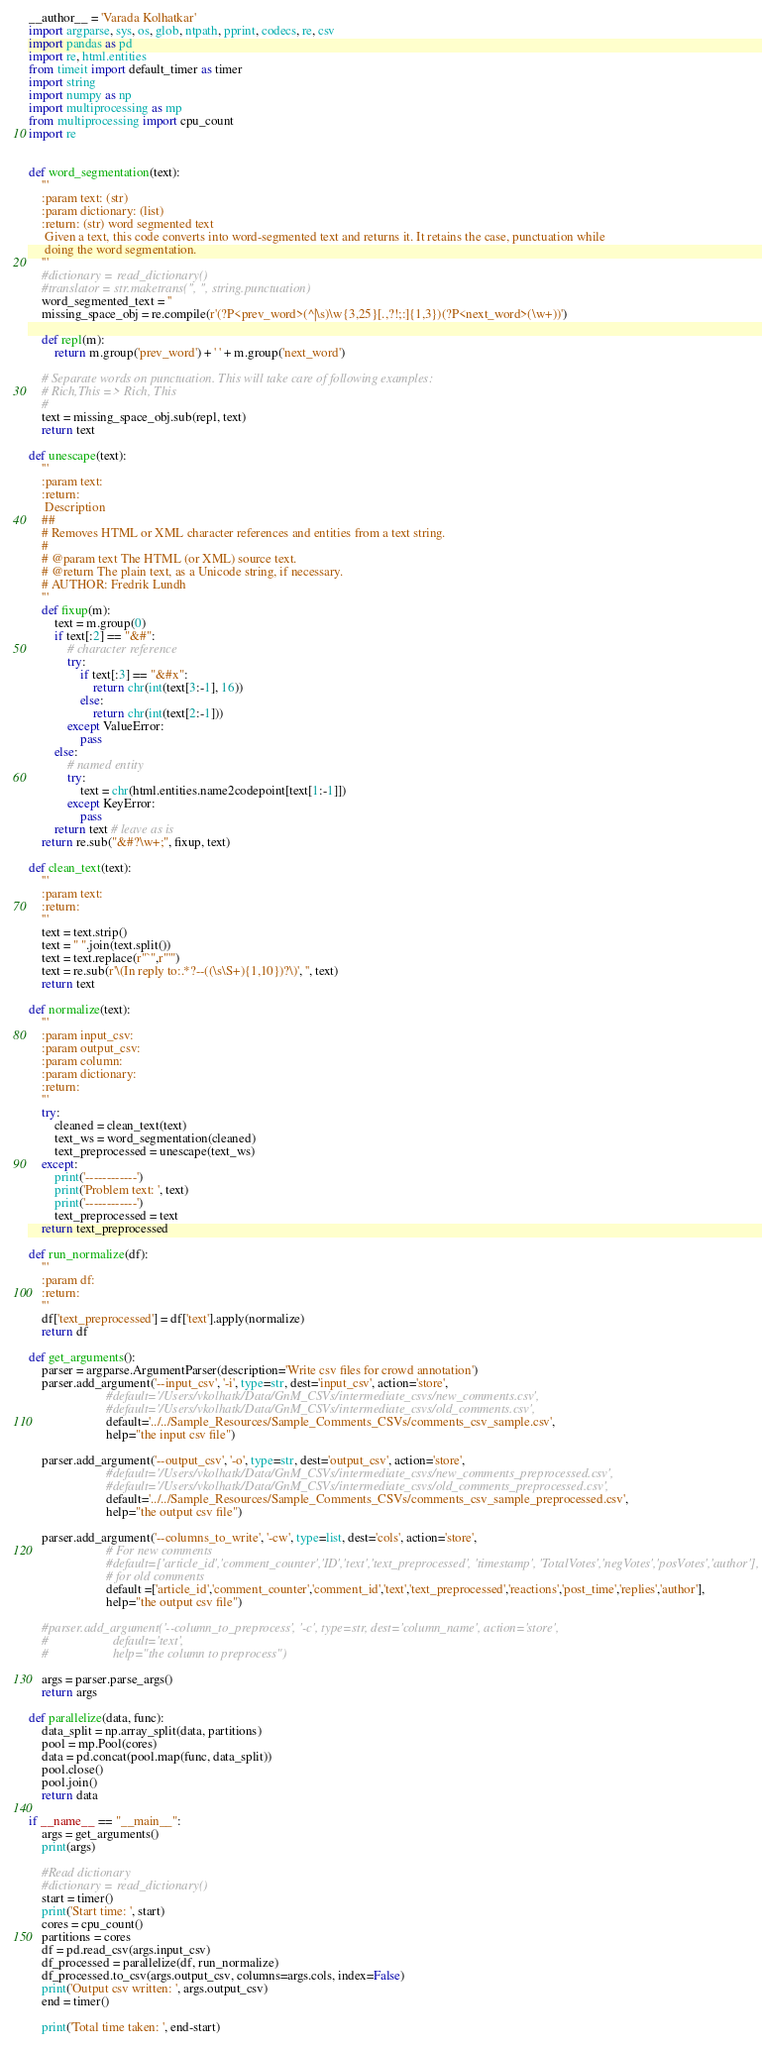<code> <loc_0><loc_0><loc_500><loc_500><_Python_>__author__ = 'Varada Kolhatkar'
import argparse, sys, os, glob, ntpath, pprint, codecs, re, csv
import pandas as pd
import re, html.entities
from timeit import default_timer as timer
import string
import numpy as np
import multiprocessing as mp
from multiprocessing import cpu_count
import re


def word_segmentation(text):
    '''
    :param text: (str)
    :param dictionary: (list)
    :return: (str) word segmented text
     Given a text, this code converts into word-segmented text and returns it. It retains the case, punctuation while
     doing the word segmentation.
    '''
    #dictionary = read_dictionary()
    #translator = str.maketrans('', '', string.punctuation)
    word_segmented_text = ''
    missing_space_obj = re.compile(r'(?P<prev_word>(^|\s)\w{3,25}[.,?!;:]{1,3})(?P<next_word>(\w+))')

    def repl(m):
        return m.group('prev_word') + ' ' + m.group('next_word')

    # Separate words on punctuation. This will take care of following examples:
    # Rich,This => Rich, This
    #
    text = missing_space_obj.sub(repl, text)
    return text

def unescape(text):
    '''
    :param text:
    :return:
     Description
    ##
    # Removes HTML or XML character references and entities from a text string.
    #
    # @param text The HTML (or XML) source text.
    # @return The plain text, as a Unicode string, if necessary.
    # AUTHOR: Fredrik Lundh
    '''
    def fixup(m):
        text = m.group(0)
        if text[:2] == "&#":
            # character reference
            try:
                if text[:3] == "&#x":
                    return chr(int(text[3:-1], 16))
                else:
                    return chr(int(text[2:-1]))
            except ValueError:
                pass
        else:
            # named entity
            try:
                text = chr(html.entities.name2codepoint[text[1:-1]])
            except KeyError:
                pass
        return text # leave as is
    return re.sub("&#?\w+;", fixup, text)

def clean_text(text):
    '''
    :param text:
    :return:
    '''
    text = text.strip()
    text = " ".join(text.split())
    text = text.replace(r"`",r"'")
    text = re.sub(r'\(In reply to:.*?--((\s\S+){1,10})?\)', '', text)
    return text

def normalize(text):
    '''
    :param input_csv:
    :param output_csv:
    :param column:
    :param dictionary:
    :return:
    '''
    try:
        cleaned = clean_text(text)
        text_ws = word_segmentation(cleaned)
        text_preprocessed = unescape(text_ws)
    except:
        print('------------')
        print('Problem text: ', text)
        print('------------')
        text_preprocessed = text
    return text_preprocessed

def run_normalize(df):
    '''
    :param df:
    :return:
    '''
    df['text_preprocessed'] = df['text'].apply(normalize)
    return df

def get_arguments():
    parser = argparse.ArgumentParser(description='Write csv files for crowd annotation')
    parser.add_argument('--input_csv', '-i', type=str, dest='input_csv', action='store',
                        #default='/Users/vkolhatk/Data/GnM_CSVs/intermediate_csvs/new_comments.csv',
                        #default='/Users/vkolhatk/Data/GnM_CSVs/intermediate_csvs/old_comments.csv',
                        default='../../Sample_Resources/Sample_Comments_CSVs/comments_csv_sample.csv',
                        help="the input csv file")

    parser.add_argument('--output_csv', '-o', type=str, dest='output_csv', action='store',
                        #default='/Users/vkolhatk/Data/GnM_CSVs/intermediate_csvs/new_comments_preprocessed.csv',
                        #default='/Users/vkolhatk/Data/GnM_CSVs/intermediate_csvs/old_comments_preprocessed.csv',
                        default='../../Sample_Resources/Sample_Comments_CSVs/comments_csv_sample_preprocessed.csv',
                        help="the output csv file")

    parser.add_argument('--columns_to_write', '-cw', type=list, dest='cols', action='store',
                        # For new comments
                        #default=['article_id','comment_counter','ID','text','text_preprocessed', 'timestamp', 'TotalVotes','negVotes','posVotes','author'],
                        # for old comments
                        default =['article_id','comment_counter','comment_id','text','text_preprocessed','reactions','post_time','replies','author'],
                        help="the output csv file")

    #parser.add_argument('--column_to_preprocess', '-c', type=str, dest='column_name', action='store',
    #                    default='text',
    #                    help="the column to preprocess")

    args = parser.parse_args()
    return args

def parallelize(data, func):
    data_split = np.array_split(data, partitions)
    pool = mp.Pool(cores)
    data = pd.concat(pool.map(func, data_split))
    pool.close()
    pool.join()
    return data

if __name__ == "__main__":
    args = get_arguments()
    print(args)

    #Read dictionary
    #dictionary = read_dictionary()
    start = timer()
    print('Start time: ', start)
    cores = cpu_count()
    partitions = cores
    df = pd.read_csv(args.input_csv)
    df_processed = parallelize(df, run_normalize)
    df_processed.to_csv(args.output_csv, columns=args.cols, index=False)
    print('Output csv written: ', args.output_csv)
    end = timer()

    print('Total time taken: ', end-start)
</code> 